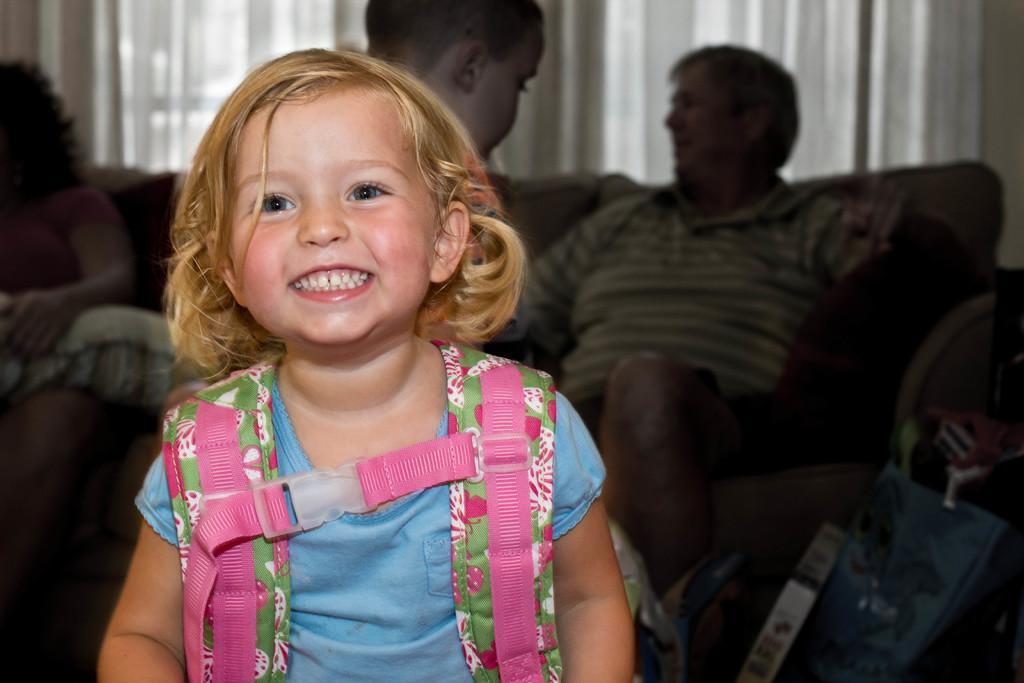How would you summarize this image in a sentence or two? In this picture I can see a girl standing and smiling with a backpack, there is a kid standing, there are two persons sitting on the couch and there are some objects, and in the background those are looking like curtains. 